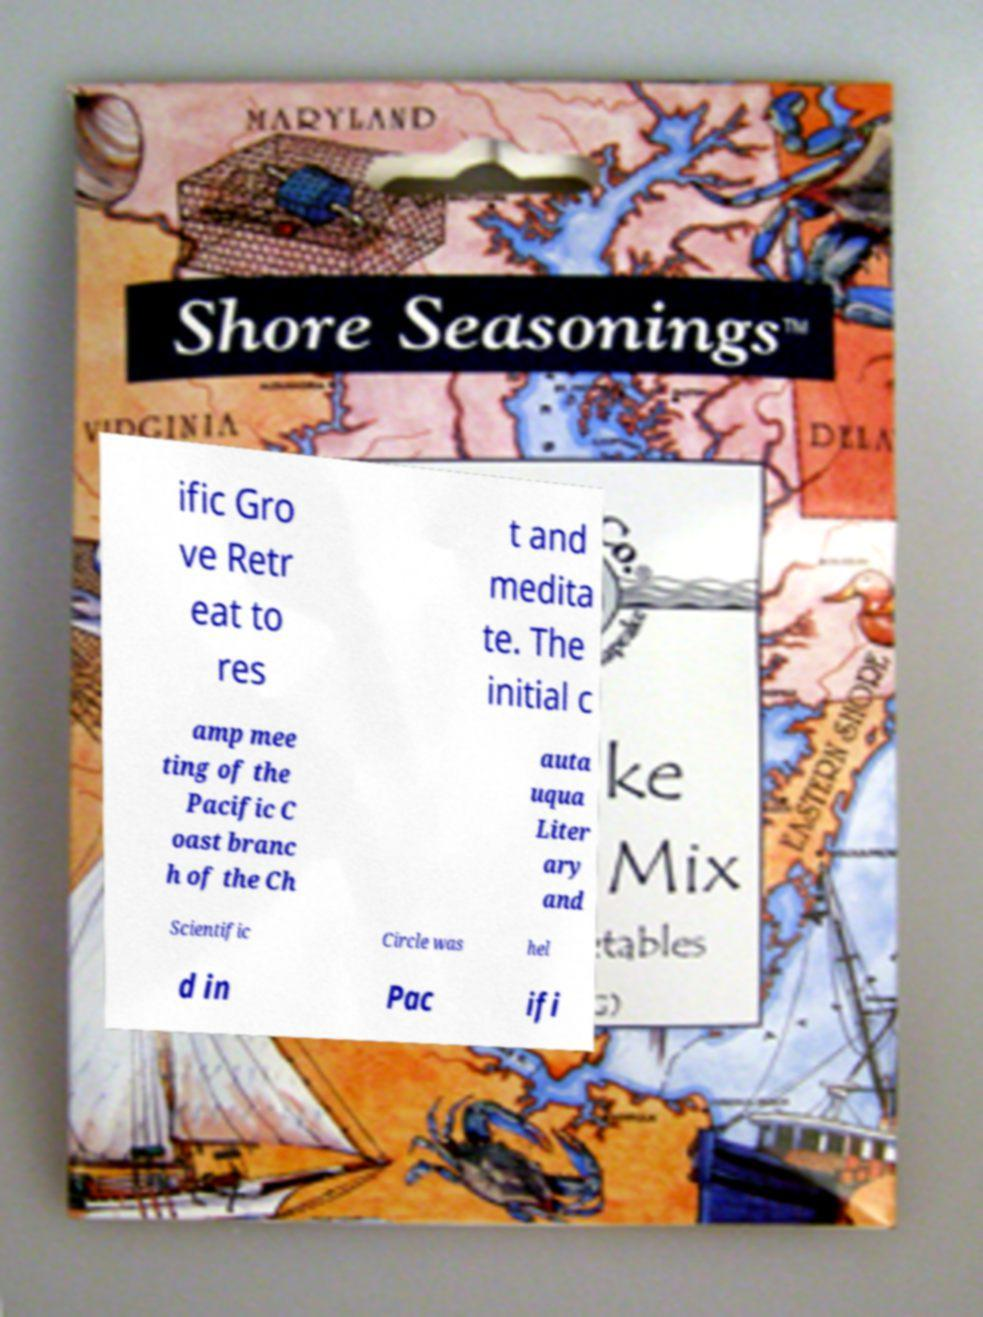Please read and relay the text visible in this image. What does it say? ific Gro ve Retr eat to res t and medita te. The initial c amp mee ting of the Pacific C oast branc h of the Ch auta uqua Liter ary and Scientific Circle was hel d in Pac ifi 